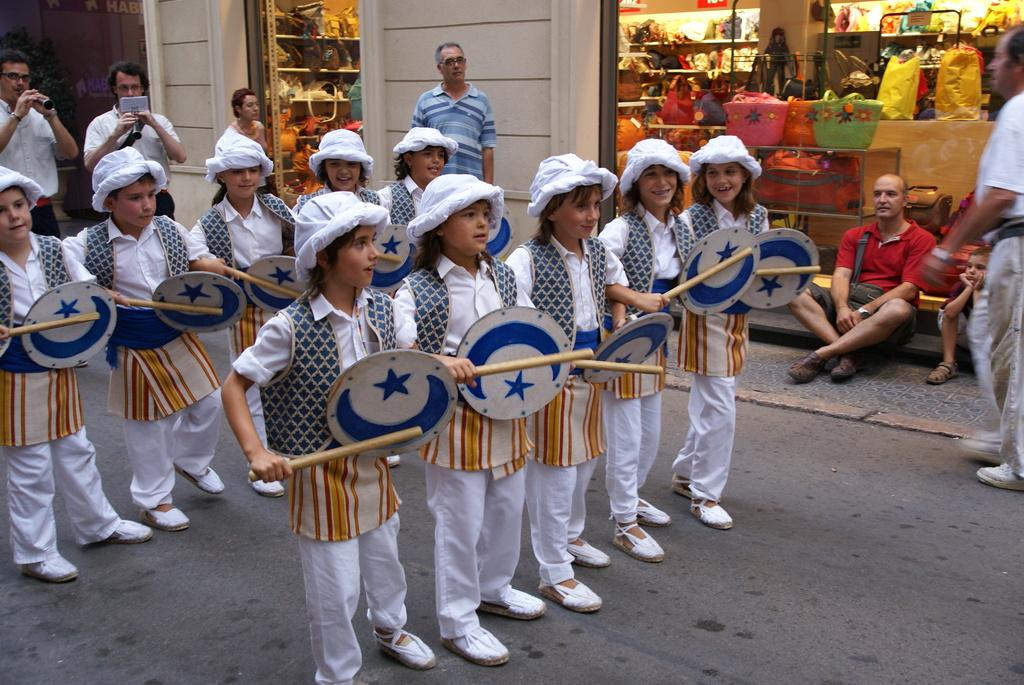How many people are in the image? There is a group of people in the image, but the exact number cannot be determined from the provided facts. What is the primary feature of the image? The primary feature of the image is a road. What objects can be seen in the background of the image? In the background of the image, there are bags, a rack, a glass object, and a wall. What type of doll is sitting on the nail in the image? There is no doll or nail present in the image. How many sacks are visible on the rack in the image? The facts do not mention the presence of sacks or a rack with sacks in the image. 